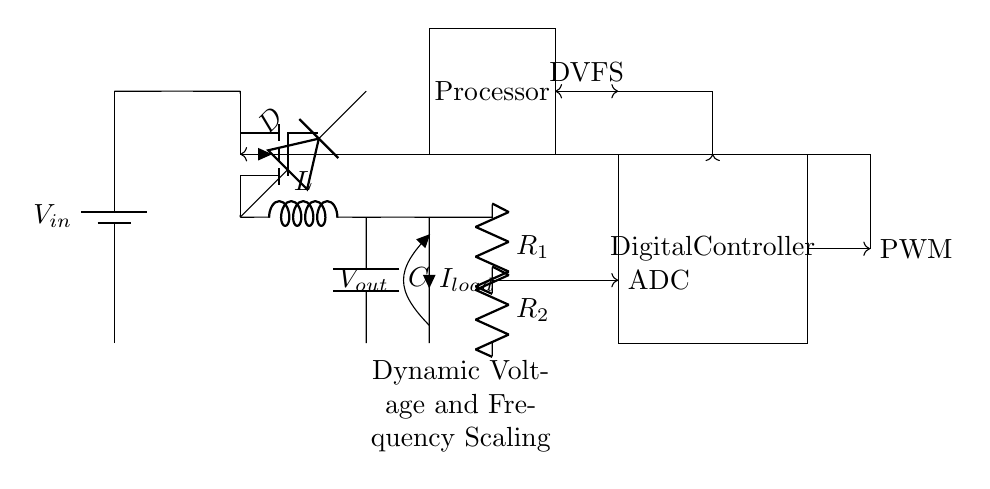What is the input voltage represented in the circuit? The input voltage is shown as \( V_{in} \) by the battery symbol at the left side of the circuit diagram.
Answer: \( V_{in} \) What type of converter is used in this circuit? The circuit uses a buck converter, indicated by the presence of a MOSFET and an inductor in the diagram.
Answer: Buck converter What does the output voltage refer to in the circuit? The output voltage is denoted as \( V_{out} \) and is connected to the load (represented as \( I_{load} \)) on the right side.
Answer: \( V_{out} \) How many resistors are used in the feedback control mechanism? There are two resistors, \( R_1 \) and \( R_2 \), shown in the feedback section of the circuit diagram connected to the output.
Answer: 2 What is the role of the digital controller in this circuit? The digital controller manages the output voltage by processing signals and generating a PWM (Pulse Width Modulation) signal, facilitating optimal voltage and frequency scaling.
Answer: Manage output voltage How is the dynamic voltage and frequency scaling achieved? DVFS is achieved through the feedback loop and the digital controller that adjusts the PWM signal based on the current load and conditions of the processor, allowing dynamic adjustments to output voltage and frequency.
Answer: Feedback and PWM adjustments What current flows to the load according to the diagram? The current flowing to the load is labeled as \( I_{load} \) at the output of the circuit, indicating the current that the load receives from the regulator.
Answer: \( I_{load} \) 